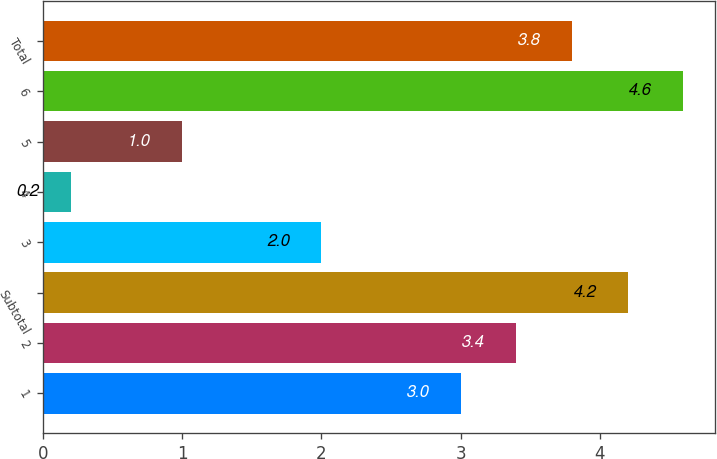<chart> <loc_0><loc_0><loc_500><loc_500><bar_chart><fcel>1<fcel>2<fcel>Subtotal<fcel>3<fcel>4<fcel>5<fcel>6<fcel>Total<nl><fcel>3<fcel>3.4<fcel>4.2<fcel>2<fcel>0.2<fcel>1<fcel>4.6<fcel>3.8<nl></chart> 